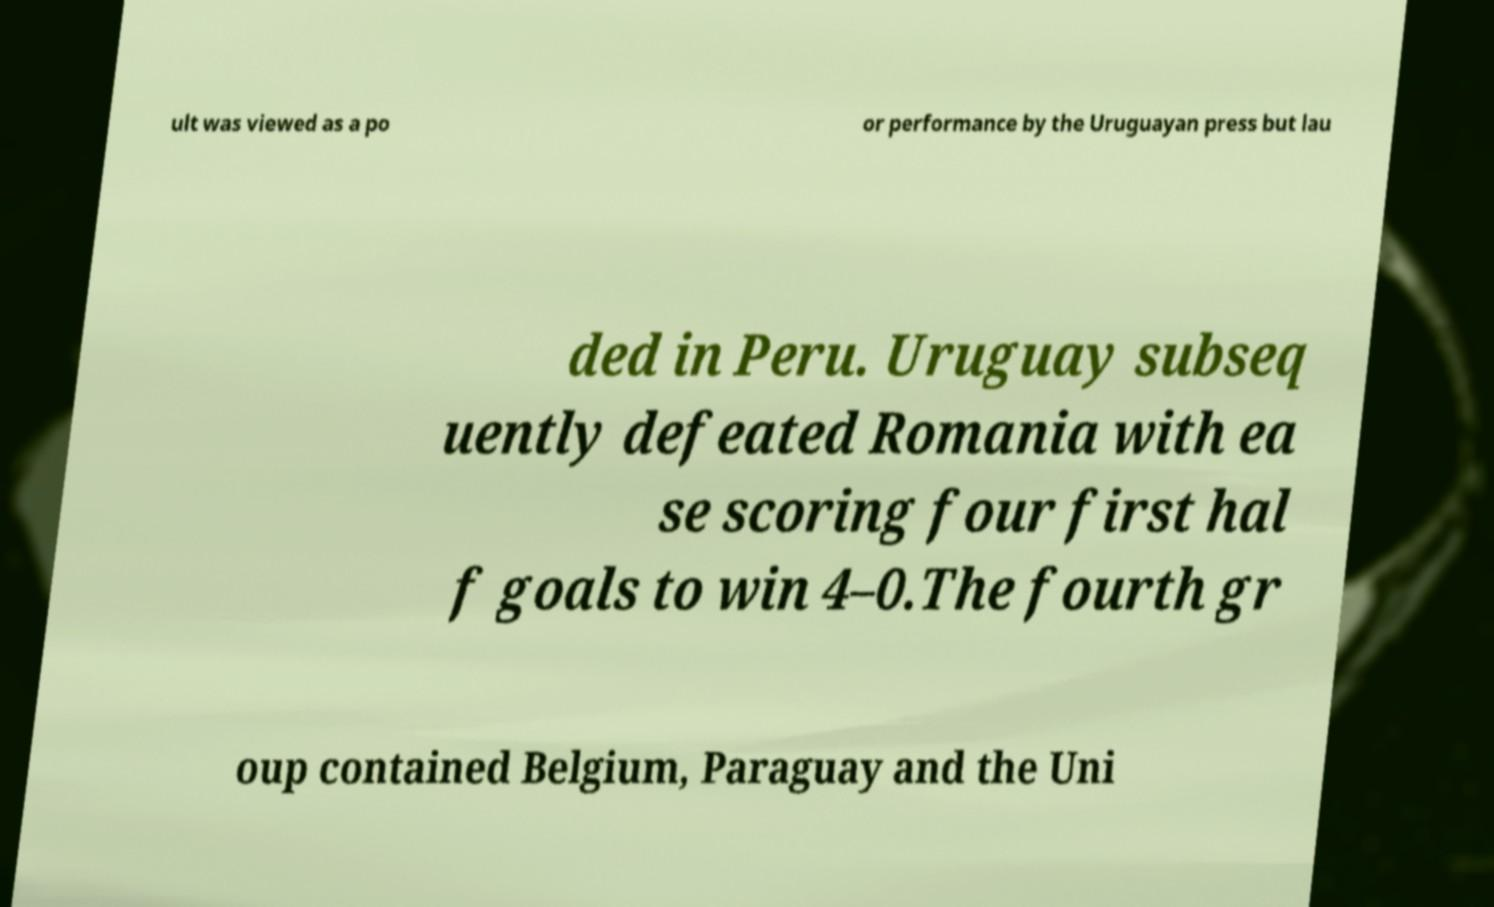I need the written content from this picture converted into text. Can you do that? ult was viewed as a po or performance by the Uruguayan press but lau ded in Peru. Uruguay subseq uently defeated Romania with ea se scoring four first hal f goals to win 4–0.The fourth gr oup contained Belgium, Paraguay and the Uni 